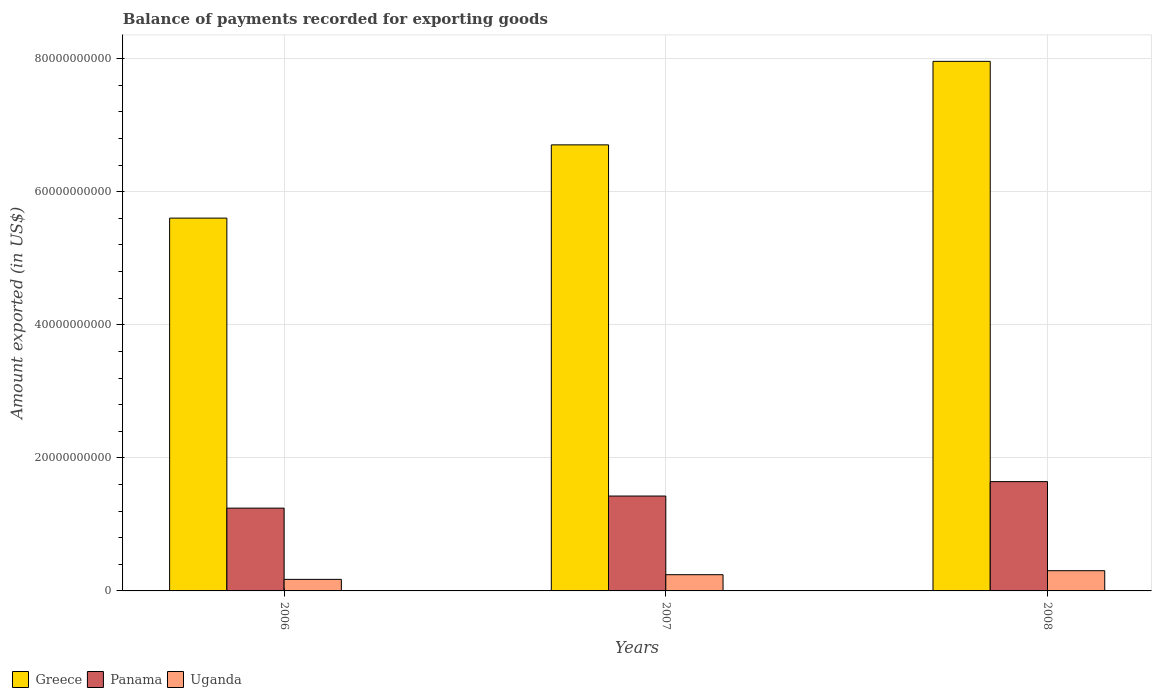How many groups of bars are there?
Your answer should be compact. 3. Are the number of bars on each tick of the X-axis equal?
Your response must be concise. Yes. What is the label of the 2nd group of bars from the left?
Your response must be concise. 2007. In how many cases, is the number of bars for a given year not equal to the number of legend labels?
Your answer should be very brief. 0. What is the amount exported in Panama in 2007?
Your answer should be very brief. 1.43e+1. Across all years, what is the maximum amount exported in Uganda?
Provide a succinct answer. 3.04e+09. Across all years, what is the minimum amount exported in Greece?
Keep it short and to the point. 5.60e+1. What is the total amount exported in Uganda in the graph?
Provide a succinct answer. 7.21e+09. What is the difference between the amount exported in Greece in 2007 and that in 2008?
Offer a very short reply. -1.26e+1. What is the difference between the amount exported in Uganda in 2008 and the amount exported in Greece in 2006?
Your response must be concise. -5.30e+1. What is the average amount exported in Uganda per year?
Offer a terse response. 2.40e+09. In the year 2008, what is the difference between the amount exported in Greece and amount exported in Uganda?
Offer a terse response. 7.66e+1. In how many years, is the amount exported in Greece greater than 64000000000 US$?
Provide a succinct answer. 2. What is the ratio of the amount exported in Panama in 2006 to that in 2007?
Your answer should be compact. 0.87. Is the amount exported in Uganda in 2007 less than that in 2008?
Offer a very short reply. Yes. What is the difference between the highest and the second highest amount exported in Uganda?
Make the answer very short. 6.01e+08. What is the difference between the highest and the lowest amount exported in Greece?
Your answer should be very brief. 2.36e+1. In how many years, is the amount exported in Panama greater than the average amount exported in Panama taken over all years?
Provide a succinct answer. 1. What does the 2nd bar from the left in 2008 represents?
Ensure brevity in your answer.  Panama. How many bars are there?
Offer a very short reply. 9. Are all the bars in the graph horizontal?
Provide a succinct answer. No. What is the difference between two consecutive major ticks on the Y-axis?
Offer a terse response. 2.00e+1. Are the values on the major ticks of Y-axis written in scientific E-notation?
Provide a succinct answer. No. What is the title of the graph?
Your answer should be compact. Balance of payments recorded for exporting goods. What is the label or title of the X-axis?
Your answer should be very brief. Years. What is the label or title of the Y-axis?
Offer a terse response. Amount exported (in US$). What is the Amount exported (in US$) in Greece in 2006?
Offer a terse response. 5.60e+1. What is the Amount exported (in US$) of Panama in 2006?
Your answer should be very brief. 1.24e+1. What is the Amount exported (in US$) in Uganda in 2006?
Ensure brevity in your answer.  1.74e+09. What is the Amount exported (in US$) in Greece in 2007?
Keep it short and to the point. 6.70e+1. What is the Amount exported (in US$) of Panama in 2007?
Give a very brief answer. 1.43e+1. What is the Amount exported (in US$) of Uganda in 2007?
Your answer should be compact. 2.44e+09. What is the Amount exported (in US$) of Greece in 2008?
Your response must be concise. 7.96e+1. What is the Amount exported (in US$) of Panama in 2008?
Your answer should be very brief. 1.64e+1. What is the Amount exported (in US$) of Uganda in 2008?
Your answer should be compact. 3.04e+09. Across all years, what is the maximum Amount exported (in US$) of Greece?
Provide a succinct answer. 7.96e+1. Across all years, what is the maximum Amount exported (in US$) in Panama?
Offer a very short reply. 1.64e+1. Across all years, what is the maximum Amount exported (in US$) of Uganda?
Provide a succinct answer. 3.04e+09. Across all years, what is the minimum Amount exported (in US$) in Greece?
Make the answer very short. 5.60e+1. Across all years, what is the minimum Amount exported (in US$) in Panama?
Your response must be concise. 1.24e+1. Across all years, what is the minimum Amount exported (in US$) of Uganda?
Give a very brief answer. 1.74e+09. What is the total Amount exported (in US$) of Greece in the graph?
Provide a short and direct response. 2.03e+11. What is the total Amount exported (in US$) in Panama in the graph?
Provide a short and direct response. 4.31e+1. What is the total Amount exported (in US$) in Uganda in the graph?
Provide a succinct answer. 7.21e+09. What is the difference between the Amount exported (in US$) in Greece in 2006 and that in 2007?
Your answer should be very brief. -1.10e+1. What is the difference between the Amount exported (in US$) in Panama in 2006 and that in 2007?
Ensure brevity in your answer.  -1.82e+09. What is the difference between the Amount exported (in US$) in Uganda in 2006 and that in 2007?
Your answer should be very brief. -7.03e+08. What is the difference between the Amount exported (in US$) in Greece in 2006 and that in 2008?
Your answer should be compact. -2.36e+1. What is the difference between the Amount exported (in US$) of Panama in 2006 and that in 2008?
Ensure brevity in your answer.  -3.98e+09. What is the difference between the Amount exported (in US$) in Uganda in 2006 and that in 2008?
Give a very brief answer. -1.30e+09. What is the difference between the Amount exported (in US$) of Greece in 2007 and that in 2008?
Provide a short and direct response. -1.26e+1. What is the difference between the Amount exported (in US$) in Panama in 2007 and that in 2008?
Make the answer very short. -2.17e+09. What is the difference between the Amount exported (in US$) of Uganda in 2007 and that in 2008?
Provide a succinct answer. -6.01e+08. What is the difference between the Amount exported (in US$) in Greece in 2006 and the Amount exported (in US$) in Panama in 2007?
Keep it short and to the point. 4.18e+1. What is the difference between the Amount exported (in US$) of Greece in 2006 and the Amount exported (in US$) of Uganda in 2007?
Offer a terse response. 5.36e+1. What is the difference between the Amount exported (in US$) in Panama in 2006 and the Amount exported (in US$) in Uganda in 2007?
Your answer should be very brief. 1.00e+1. What is the difference between the Amount exported (in US$) of Greece in 2006 and the Amount exported (in US$) of Panama in 2008?
Make the answer very short. 3.96e+1. What is the difference between the Amount exported (in US$) of Greece in 2006 and the Amount exported (in US$) of Uganda in 2008?
Offer a very short reply. 5.30e+1. What is the difference between the Amount exported (in US$) of Panama in 2006 and the Amount exported (in US$) of Uganda in 2008?
Make the answer very short. 9.40e+09. What is the difference between the Amount exported (in US$) of Greece in 2007 and the Amount exported (in US$) of Panama in 2008?
Your answer should be compact. 5.06e+1. What is the difference between the Amount exported (in US$) of Greece in 2007 and the Amount exported (in US$) of Uganda in 2008?
Offer a terse response. 6.40e+1. What is the difference between the Amount exported (in US$) in Panama in 2007 and the Amount exported (in US$) in Uganda in 2008?
Your answer should be compact. 1.12e+1. What is the average Amount exported (in US$) of Greece per year?
Make the answer very short. 6.76e+1. What is the average Amount exported (in US$) of Panama per year?
Offer a terse response. 1.44e+1. What is the average Amount exported (in US$) in Uganda per year?
Your answer should be compact. 2.40e+09. In the year 2006, what is the difference between the Amount exported (in US$) of Greece and Amount exported (in US$) of Panama?
Give a very brief answer. 4.36e+1. In the year 2006, what is the difference between the Amount exported (in US$) of Greece and Amount exported (in US$) of Uganda?
Offer a terse response. 5.43e+1. In the year 2006, what is the difference between the Amount exported (in US$) of Panama and Amount exported (in US$) of Uganda?
Make the answer very short. 1.07e+1. In the year 2007, what is the difference between the Amount exported (in US$) in Greece and Amount exported (in US$) in Panama?
Give a very brief answer. 5.28e+1. In the year 2007, what is the difference between the Amount exported (in US$) in Greece and Amount exported (in US$) in Uganda?
Ensure brevity in your answer.  6.46e+1. In the year 2007, what is the difference between the Amount exported (in US$) in Panama and Amount exported (in US$) in Uganda?
Your answer should be compact. 1.18e+1. In the year 2008, what is the difference between the Amount exported (in US$) of Greece and Amount exported (in US$) of Panama?
Provide a succinct answer. 6.32e+1. In the year 2008, what is the difference between the Amount exported (in US$) in Greece and Amount exported (in US$) in Uganda?
Your answer should be very brief. 7.66e+1. In the year 2008, what is the difference between the Amount exported (in US$) of Panama and Amount exported (in US$) of Uganda?
Ensure brevity in your answer.  1.34e+1. What is the ratio of the Amount exported (in US$) in Greece in 2006 to that in 2007?
Your response must be concise. 0.84. What is the ratio of the Amount exported (in US$) in Panama in 2006 to that in 2007?
Provide a short and direct response. 0.87. What is the ratio of the Amount exported (in US$) of Uganda in 2006 to that in 2007?
Your response must be concise. 0.71. What is the ratio of the Amount exported (in US$) of Greece in 2006 to that in 2008?
Provide a succinct answer. 0.7. What is the ratio of the Amount exported (in US$) of Panama in 2006 to that in 2008?
Make the answer very short. 0.76. What is the ratio of the Amount exported (in US$) of Uganda in 2006 to that in 2008?
Your answer should be very brief. 0.57. What is the ratio of the Amount exported (in US$) of Greece in 2007 to that in 2008?
Ensure brevity in your answer.  0.84. What is the ratio of the Amount exported (in US$) of Panama in 2007 to that in 2008?
Your answer should be compact. 0.87. What is the ratio of the Amount exported (in US$) in Uganda in 2007 to that in 2008?
Offer a very short reply. 0.8. What is the difference between the highest and the second highest Amount exported (in US$) of Greece?
Keep it short and to the point. 1.26e+1. What is the difference between the highest and the second highest Amount exported (in US$) in Panama?
Offer a very short reply. 2.17e+09. What is the difference between the highest and the second highest Amount exported (in US$) in Uganda?
Keep it short and to the point. 6.01e+08. What is the difference between the highest and the lowest Amount exported (in US$) of Greece?
Your answer should be very brief. 2.36e+1. What is the difference between the highest and the lowest Amount exported (in US$) of Panama?
Offer a very short reply. 3.98e+09. What is the difference between the highest and the lowest Amount exported (in US$) in Uganda?
Keep it short and to the point. 1.30e+09. 